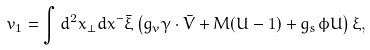Convert formula to latex. <formula><loc_0><loc_0><loc_500><loc_500>v _ { 1 } = \int d ^ { 2 } x _ { \perp } d x ^ { - } \bar { \xi } \left ( g _ { v } \gamma \cdot \bar { V } + M ( U - 1 ) + g _ { s } \phi U \right ) \xi ,</formula> 